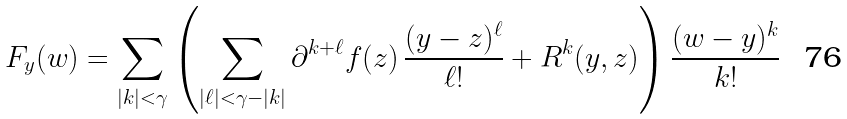Convert formula to latex. <formula><loc_0><loc_0><loc_500><loc_500>F _ { y } ( w ) & = \sum _ { | k | < \gamma } \left ( \sum _ { | \ell | < \gamma - | k | } \partial ^ { k + \ell } f ( z ) \, \frac { ( { y - z } ) ^ { \ell } } { \ell ! } + R ^ { k } ( y , z ) \right ) \frac { ( w - y ) ^ { k } } { k ! }</formula> 